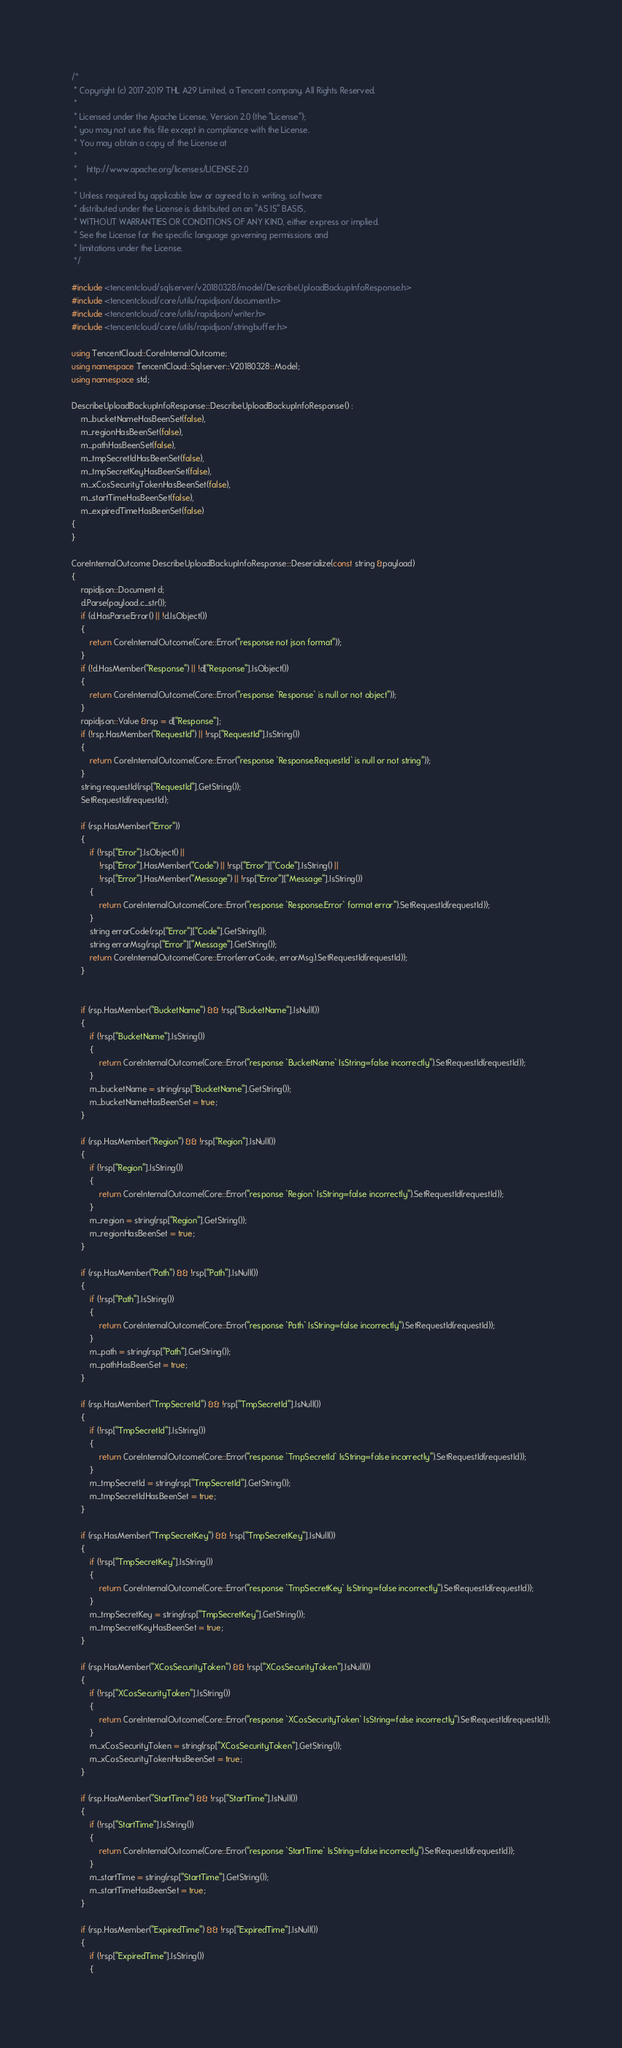Convert code to text. <code><loc_0><loc_0><loc_500><loc_500><_C++_>/*
 * Copyright (c) 2017-2019 THL A29 Limited, a Tencent company. All Rights Reserved.
 *
 * Licensed under the Apache License, Version 2.0 (the "License");
 * you may not use this file except in compliance with the License.
 * You may obtain a copy of the License at
 *
 *    http://www.apache.org/licenses/LICENSE-2.0
 *
 * Unless required by applicable law or agreed to in writing, software
 * distributed under the License is distributed on an "AS IS" BASIS,
 * WITHOUT WARRANTIES OR CONDITIONS OF ANY KIND, either express or implied.
 * See the License for the specific language governing permissions and
 * limitations under the License.
 */

#include <tencentcloud/sqlserver/v20180328/model/DescribeUploadBackupInfoResponse.h>
#include <tencentcloud/core/utils/rapidjson/document.h>
#include <tencentcloud/core/utils/rapidjson/writer.h>
#include <tencentcloud/core/utils/rapidjson/stringbuffer.h>

using TencentCloud::CoreInternalOutcome;
using namespace TencentCloud::Sqlserver::V20180328::Model;
using namespace std;

DescribeUploadBackupInfoResponse::DescribeUploadBackupInfoResponse() :
    m_bucketNameHasBeenSet(false),
    m_regionHasBeenSet(false),
    m_pathHasBeenSet(false),
    m_tmpSecretIdHasBeenSet(false),
    m_tmpSecretKeyHasBeenSet(false),
    m_xCosSecurityTokenHasBeenSet(false),
    m_startTimeHasBeenSet(false),
    m_expiredTimeHasBeenSet(false)
{
}

CoreInternalOutcome DescribeUploadBackupInfoResponse::Deserialize(const string &payload)
{
    rapidjson::Document d;
    d.Parse(payload.c_str());
    if (d.HasParseError() || !d.IsObject())
    {
        return CoreInternalOutcome(Core::Error("response not json format"));
    }
    if (!d.HasMember("Response") || !d["Response"].IsObject())
    {
        return CoreInternalOutcome(Core::Error("response `Response` is null or not object"));
    }
    rapidjson::Value &rsp = d["Response"];
    if (!rsp.HasMember("RequestId") || !rsp["RequestId"].IsString())
    {
        return CoreInternalOutcome(Core::Error("response `Response.RequestId` is null or not string"));
    }
    string requestId(rsp["RequestId"].GetString());
    SetRequestId(requestId);

    if (rsp.HasMember("Error"))
    {
        if (!rsp["Error"].IsObject() ||
            !rsp["Error"].HasMember("Code") || !rsp["Error"]["Code"].IsString() ||
            !rsp["Error"].HasMember("Message") || !rsp["Error"]["Message"].IsString())
        {
            return CoreInternalOutcome(Core::Error("response `Response.Error` format error").SetRequestId(requestId));
        }
        string errorCode(rsp["Error"]["Code"].GetString());
        string errorMsg(rsp["Error"]["Message"].GetString());
        return CoreInternalOutcome(Core::Error(errorCode, errorMsg).SetRequestId(requestId));
    }


    if (rsp.HasMember("BucketName") && !rsp["BucketName"].IsNull())
    {
        if (!rsp["BucketName"].IsString())
        {
            return CoreInternalOutcome(Core::Error("response `BucketName` IsString=false incorrectly").SetRequestId(requestId));
        }
        m_bucketName = string(rsp["BucketName"].GetString());
        m_bucketNameHasBeenSet = true;
    }

    if (rsp.HasMember("Region") && !rsp["Region"].IsNull())
    {
        if (!rsp["Region"].IsString())
        {
            return CoreInternalOutcome(Core::Error("response `Region` IsString=false incorrectly").SetRequestId(requestId));
        }
        m_region = string(rsp["Region"].GetString());
        m_regionHasBeenSet = true;
    }

    if (rsp.HasMember("Path") && !rsp["Path"].IsNull())
    {
        if (!rsp["Path"].IsString())
        {
            return CoreInternalOutcome(Core::Error("response `Path` IsString=false incorrectly").SetRequestId(requestId));
        }
        m_path = string(rsp["Path"].GetString());
        m_pathHasBeenSet = true;
    }

    if (rsp.HasMember("TmpSecretId") && !rsp["TmpSecretId"].IsNull())
    {
        if (!rsp["TmpSecretId"].IsString())
        {
            return CoreInternalOutcome(Core::Error("response `TmpSecretId` IsString=false incorrectly").SetRequestId(requestId));
        }
        m_tmpSecretId = string(rsp["TmpSecretId"].GetString());
        m_tmpSecretIdHasBeenSet = true;
    }

    if (rsp.HasMember("TmpSecretKey") && !rsp["TmpSecretKey"].IsNull())
    {
        if (!rsp["TmpSecretKey"].IsString())
        {
            return CoreInternalOutcome(Core::Error("response `TmpSecretKey` IsString=false incorrectly").SetRequestId(requestId));
        }
        m_tmpSecretKey = string(rsp["TmpSecretKey"].GetString());
        m_tmpSecretKeyHasBeenSet = true;
    }

    if (rsp.HasMember("XCosSecurityToken") && !rsp["XCosSecurityToken"].IsNull())
    {
        if (!rsp["XCosSecurityToken"].IsString())
        {
            return CoreInternalOutcome(Core::Error("response `XCosSecurityToken` IsString=false incorrectly").SetRequestId(requestId));
        }
        m_xCosSecurityToken = string(rsp["XCosSecurityToken"].GetString());
        m_xCosSecurityTokenHasBeenSet = true;
    }

    if (rsp.HasMember("StartTime") && !rsp["StartTime"].IsNull())
    {
        if (!rsp["StartTime"].IsString())
        {
            return CoreInternalOutcome(Core::Error("response `StartTime` IsString=false incorrectly").SetRequestId(requestId));
        }
        m_startTime = string(rsp["StartTime"].GetString());
        m_startTimeHasBeenSet = true;
    }

    if (rsp.HasMember("ExpiredTime") && !rsp["ExpiredTime"].IsNull())
    {
        if (!rsp["ExpiredTime"].IsString())
        {</code> 